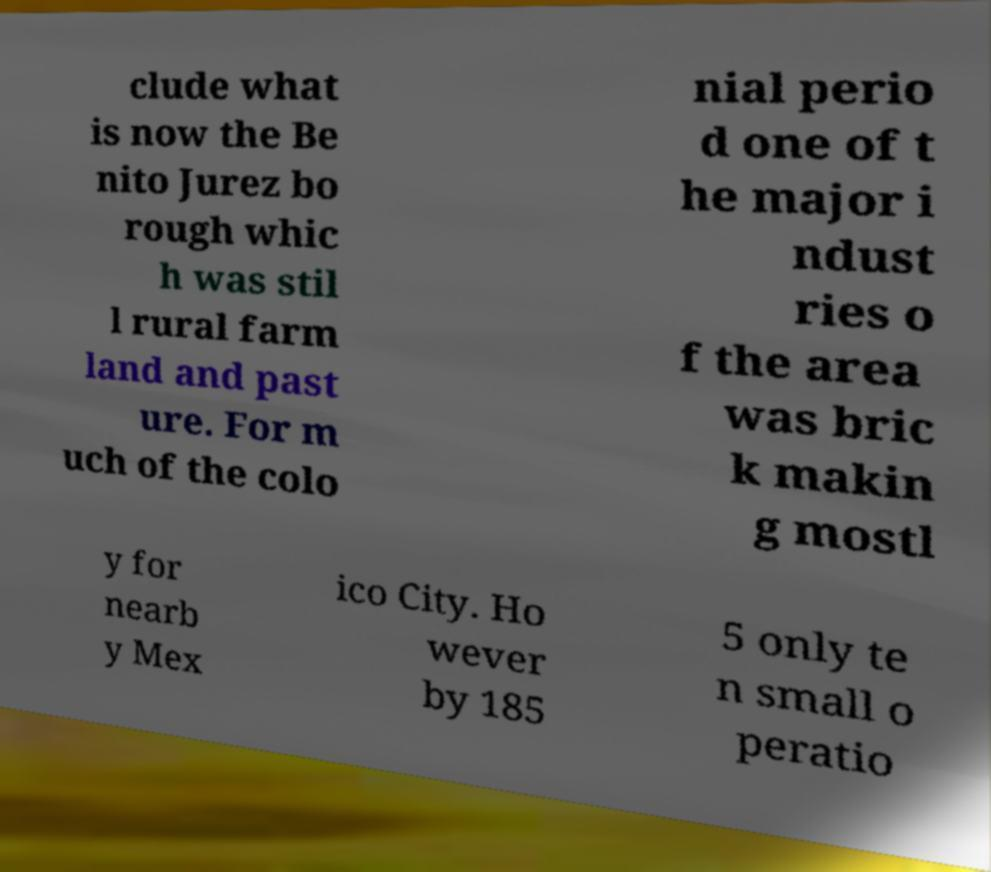There's text embedded in this image that I need extracted. Can you transcribe it verbatim? clude what is now the Be nito Jurez bo rough whic h was stil l rural farm land and past ure. For m uch of the colo nial perio d one of t he major i ndust ries o f the area was bric k makin g mostl y for nearb y Mex ico City. Ho wever by 185 5 only te n small o peratio 